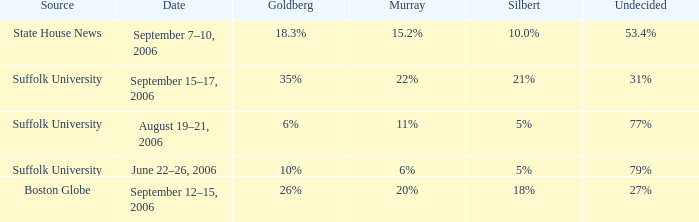What is the undecided percentage of the poll where Goldberg had 6%? 77%. Help me parse the entirety of this table. {'header': ['Source', 'Date', 'Goldberg', 'Murray', 'Silbert', 'Undecided'], 'rows': [['State House News', 'September 7–10, 2006', '18.3%', '15.2%', '10.0%', '53.4%'], ['Suffolk University', 'September 15–17, 2006', '35%', '22%', '21%', '31%'], ['Suffolk University', 'August 19–21, 2006', '6%', '11%', '5%', '77%'], ['Suffolk University', 'June 22–26, 2006', '10%', '6%', '5%', '79%'], ['Boston Globe', 'September 12–15, 2006', '26%', '20%', '18%', '27%']]} 